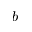Convert formula to latex. <formula><loc_0><loc_0><loc_500><loc_500>b</formula> 